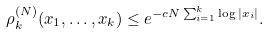Convert formula to latex. <formula><loc_0><loc_0><loc_500><loc_500>\rho ^ { ( N ) } _ { k } ( x _ { 1 } , \dots , x _ { k } ) \leq e ^ { - c N \sum _ { i = 1 } ^ { k } \log | x _ { i } | } .</formula> 